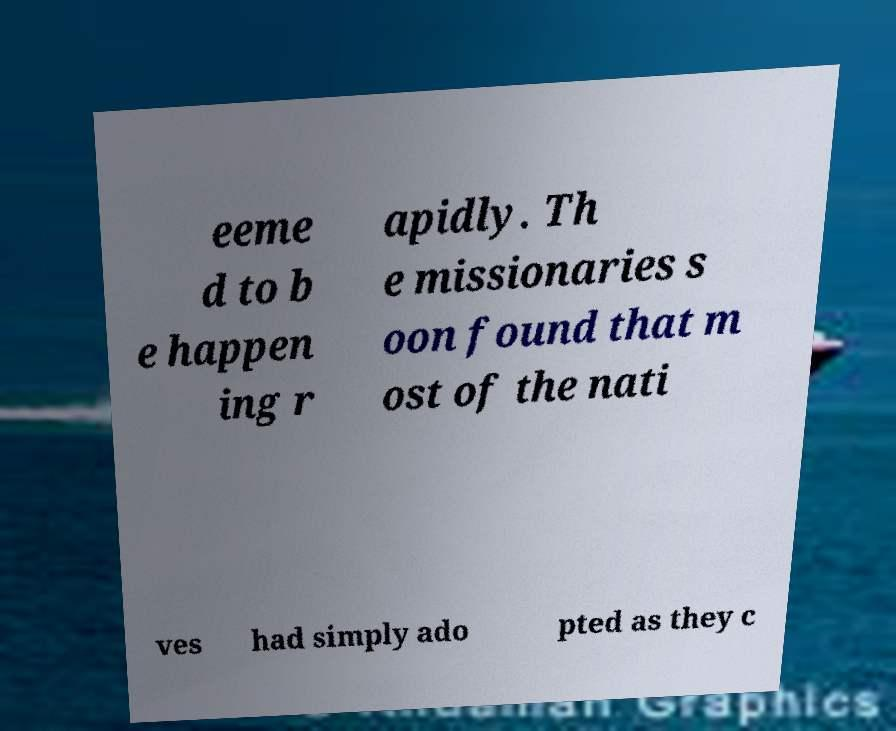There's text embedded in this image that I need extracted. Can you transcribe it verbatim? eeme d to b e happen ing r apidly. Th e missionaries s oon found that m ost of the nati ves had simply ado pted as they c 